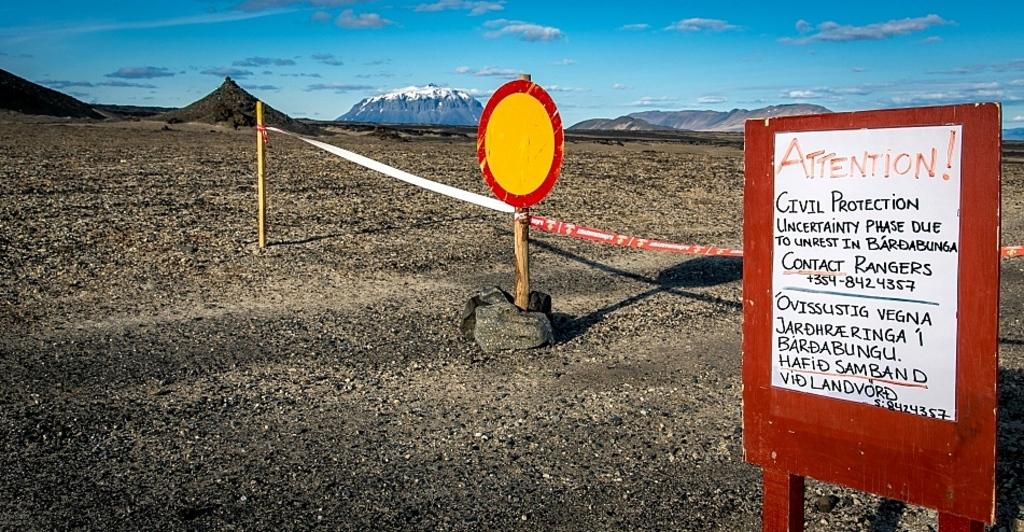What kind of protection is the sign talking about?
Provide a short and direct response. Civil. 